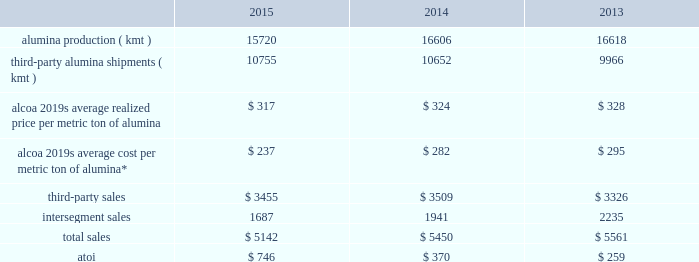Additionally , the latin american soft alloy extrusions business previously included in corporate was moved into the new transportation and construction solutions segment .
The remaining engineered products and solutions segment consists of the alcoa fastening systems and rings ( renamed to include portions of the firth rixson business acquired in november 2014 ) , alcoa power and propulsion ( includes the tital business acquired in march 2015 ) , alcoa forgings and extrusions ( includes the other portions of firth rixson ) , and alcoa titanium and engineered products ( a new business unit that consists solely of the rti international metals business acquired in july 2015 ) business units .
Segment information for all prior periods presented was updated to reflect the new segment structure .
Atoi for all reportable segments totaled $ 1906 in 2015 , $ 1968 in 2014 , and $ 1267 in 2013 .
The following information provides shipments , sales , and atoi data for each reportable segment , as well as certain production , realized price , and average cost data , for each of the three years in the period ended december 31 , 2015 .
See note q to the consolidated financial statements in part ii item 8 of this form 10-k for additional information .
Alumina .
* includes all production-related costs , including raw materials consumed ; conversion costs , such as labor , materials , and utilities ; depreciation , depletion , and amortization ; and plant administrative expenses .
This segment represents a portion of alcoa 2019s upstream operations and consists of the company 2019s worldwide refining system .
Alumina mines bauxite , from which alumina is produced and then sold directly to external smelter customers , as well as to the primary metals segment ( see primary metals below ) , or to customers who process it into industrial chemical products .
More than half of alumina 2019s production is sold under supply contracts to third parties worldwide , while the remainder is used internally by the primary metals segment .
Alumina produced by this segment and used internally is transferred to the primary metals segment at prevailing market prices .
A portion of this segment 2019s third- party sales are completed through the use of agents , alumina traders , and distributors .
Generally , the sales of this segment are transacted in u.s .
Dollars while costs and expenses of this segment are transacted in the local currency of the respective operations , which are the australian dollar , the brazilian real , the u.s .
Dollar , and the euro .
Awac is an unincorporated global joint venture between alcoa and alumina limited and consists of a number of affiliated operating entities , which own , or have an interest in , or operate the bauxite mines and alumina refineries within the alumina segment ( except for the poc 0327os de caldas refinery in brazil and a portion of the sa 0303o lul 0301s refinery in brazil ) .
Alcoa owns 60% ( 60 % ) and alumina limited owns 40% ( 40 % ) of these individual entities , which are consolidated by the company for financial reporting purposes .
As such , the results and analysis presented for the alumina segment are inclusive of alumina limited 2019s 40% ( 40 % ) interest .
In december 2014 , awac completed the sale of its ownership stake in jamalco , a bauxite mine and alumina refinery joint venture in jamaica , to noble group ltd .
Jamalco was 55% ( 55 % ) owned by a subsidiary of awac , and , while owned by awac , 55% ( 55 % ) of both the operating results and assets and liabilities of this joint venture were included in the alumina segment .
As it relates to awac 2019s previous 55% ( 55 % ) ownership stake , the refinery ( awac 2019s share of the capacity was 779 kmt-per-year ) generated sales ( third-party and intersegment ) of approximately $ 200 in 2013 , and the refinery and mine combined , at the time of divestiture , had approximately 500 employees .
See restructuring and other charges in results of operations above. .
What is the percentual reduction of intersegment sales concerning the total sales during 2013 and 2014? 
Rationale: it is the difference between the percentage of intersegment sales concerning total sales in 2013 ( 40.19% ) and 2014 ( 35.61% )
Computations: ((2235 / 5561) - (1941 / 5450))
Answer: 0.04576. 